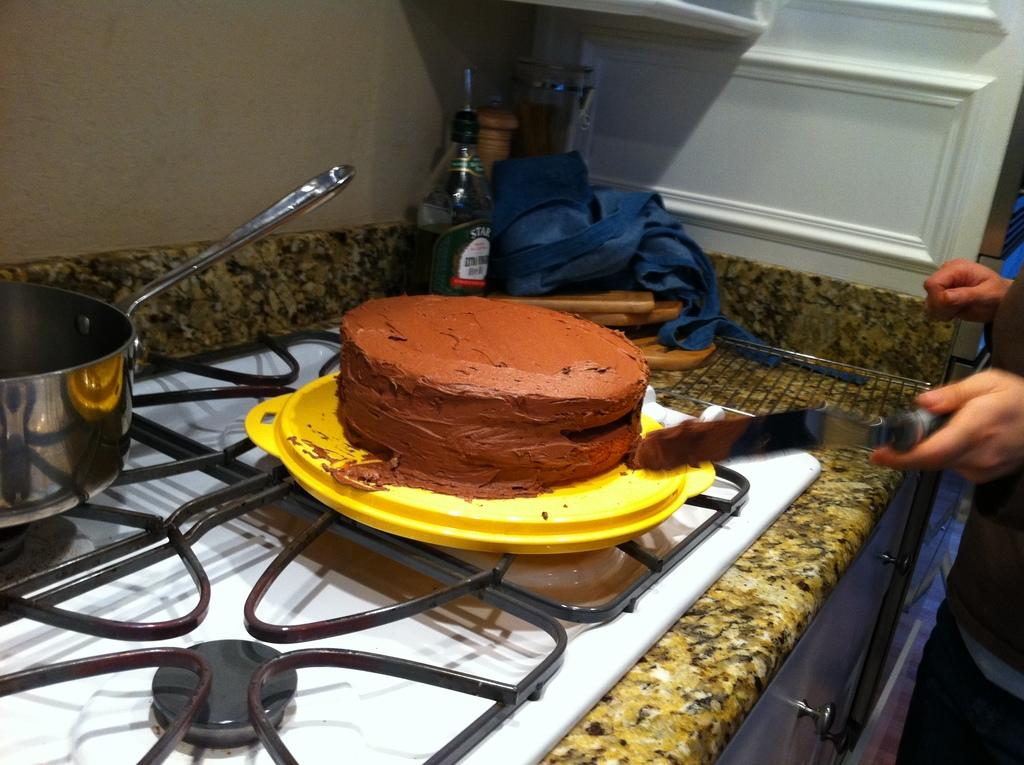What is located on the left side of the image? There is a bowl and a stove on the left side of the image. What is the main subject in the middle of the image? There is a cake in the middle of the image. What other object can be seen in the middle of the image? There is a bottle in the middle of the image. What is located on the right side of the image? There is a knife on the right side of the image. Can you see a crib in the image? There is no crib present in the image. Is there a frog on the stove in the image? There is no frog present in the image; only a bowl and a stove are visible on the left side. 